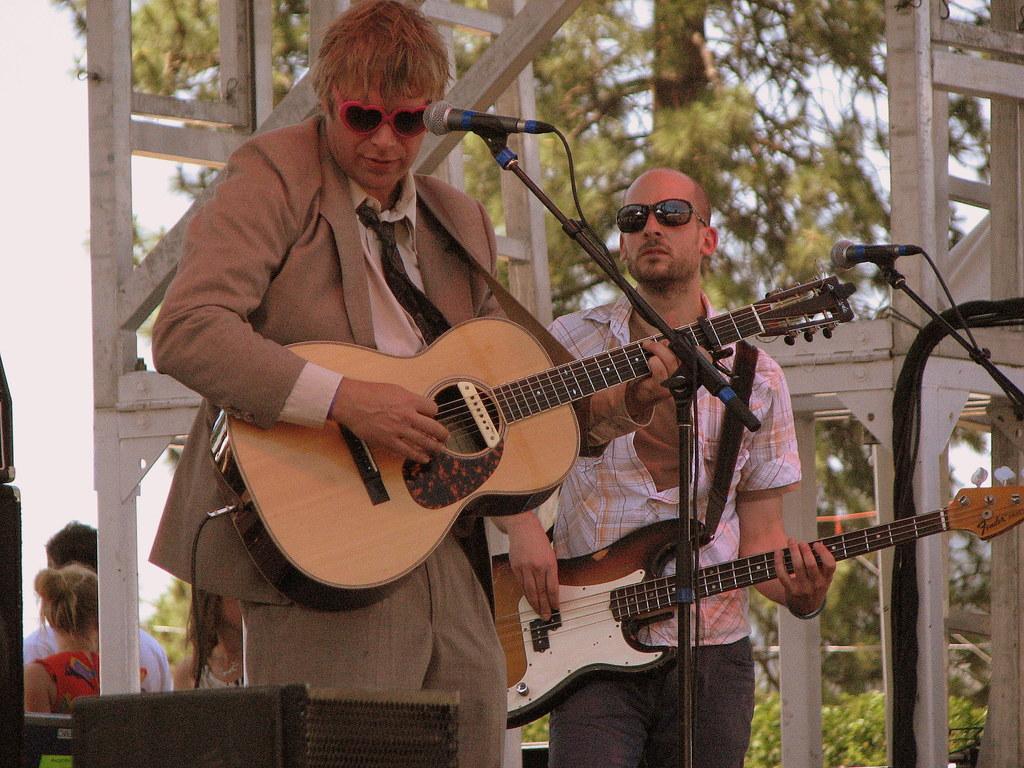Please provide a concise description of this image. In this image I can see two men are standing and playing guitars. In front of these persons there is a mike stand. In the background I can see the trees and few people. 